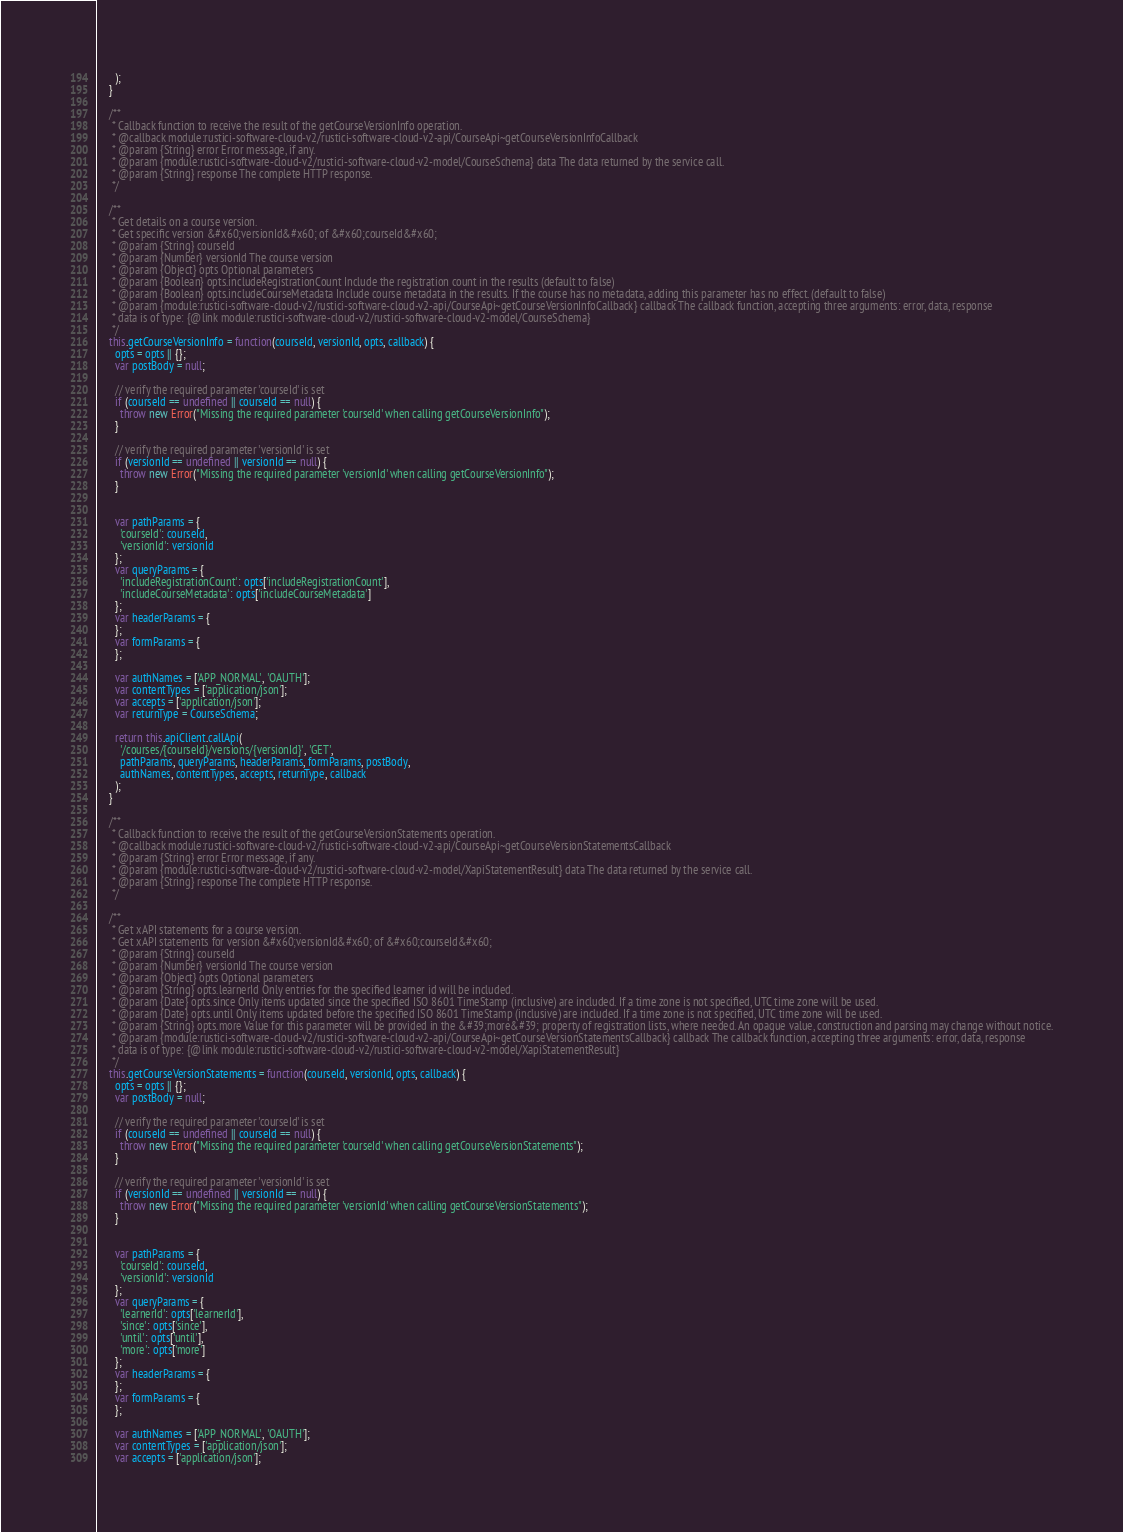<code> <loc_0><loc_0><loc_500><loc_500><_JavaScript_>      );
    }

    /**
     * Callback function to receive the result of the getCourseVersionInfo operation.
     * @callback module:rustici-software-cloud-v2/rustici-software-cloud-v2-api/CourseApi~getCourseVersionInfoCallback
     * @param {String} error Error message, if any.
     * @param {module:rustici-software-cloud-v2/rustici-software-cloud-v2-model/CourseSchema} data The data returned by the service call.
     * @param {String} response The complete HTTP response.
     */

    /**
     * Get details on a course version. 
     * Get specific version &#x60;versionId&#x60; of &#x60;courseId&#x60; 
     * @param {String} courseId 
     * @param {Number} versionId The course version
     * @param {Object} opts Optional parameters
     * @param {Boolean} opts.includeRegistrationCount Include the registration count in the results (default to false)
     * @param {Boolean} opts.includeCourseMetadata Include course metadata in the results. If the course has no metadata, adding this parameter has no effect. (default to false)
     * @param {module:rustici-software-cloud-v2/rustici-software-cloud-v2-api/CourseApi~getCourseVersionInfoCallback} callback The callback function, accepting three arguments: error, data, response
     * data is of type: {@link module:rustici-software-cloud-v2/rustici-software-cloud-v2-model/CourseSchema}
     */
    this.getCourseVersionInfo = function(courseId, versionId, opts, callback) {
      opts = opts || {};
      var postBody = null;

      // verify the required parameter 'courseId' is set
      if (courseId == undefined || courseId == null) {
        throw new Error("Missing the required parameter 'courseId' when calling getCourseVersionInfo");
      }

      // verify the required parameter 'versionId' is set
      if (versionId == undefined || versionId == null) {
        throw new Error("Missing the required parameter 'versionId' when calling getCourseVersionInfo");
      }


      var pathParams = {
        'courseId': courseId,
        'versionId': versionId
      };
      var queryParams = {
        'includeRegistrationCount': opts['includeRegistrationCount'],
        'includeCourseMetadata': opts['includeCourseMetadata']
      };
      var headerParams = {
      };
      var formParams = {
      };

      var authNames = ['APP_NORMAL', 'OAUTH'];
      var contentTypes = ['application/json'];
      var accepts = ['application/json'];
      var returnType = CourseSchema;

      return this.apiClient.callApi(
        '/courses/{courseId}/versions/{versionId}', 'GET',
        pathParams, queryParams, headerParams, formParams, postBody,
        authNames, contentTypes, accepts, returnType, callback
      );
    }

    /**
     * Callback function to receive the result of the getCourseVersionStatements operation.
     * @callback module:rustici-software-cloud-v2/rustici-software-cloud-v2-api/CourseApi~getCourseVersionStatementsCallback
     * @param {String} error Error message, if any.
     * @param {module:rustici-software-cloud-v2/rustici-software-cloud-v2-model/XapiStatementResult} data The data returned by the service call.
     * @param {String} response The complete HTTP response.
     */

    /**
     * Get xAPI statements for a course version. 
     * Get xAPI statements for version &#x60;versionId&#x60; of &#x60;courseId&#x60; 
     * @param {String} courseId 
     * @param {Number} versionId The course version
     * @param {Object} opts Optional parameters
     * @param {String} opts.learnerId Only entries for the specified learner id will be included.
     * @param {Date} opts.since Only items updated since the specified ISO 8601 TimeStamp (inclusive) are included. If a time zone is not specified, UTC time zone will be used.
     * @param {Date} opts.until Only items updated before the specified ISO 8601 TimeStamp (inclusive) are included. If a time zone is not specified, UTC time zone will be used.
     * @param {String} opts.more Value for this parameter will be provided in the &#39;more&#39; property of registration lists, where needed. An opaque value, construction and parsing may change without notice.
     * @param {module:rustici-software-cloud-v2/rustici-software-cloud-v2-api/CourseApi~getCourseVersionStatementsCallback} callback The callback function, accepting three arguments: error, data, response
     * data is of type: {@link module:rustici-software-cloud-v2/rustici-software-cloud-v2-model/XapiStatementResult}
     */
    this.getCourseVersionStatements = function(courseId, versionId, opts, callback) {
      opts = opts || {};
      var postBody = null;

      // verify the required parameter 'courseId' is set
      if (courseId == undefined || courseId == null) {
        throw new Error("Missing the required parameter 'courseId' when calling getCourseVersionStatements");
      }

      // verify the required parameter 'versionId' is set
      if (versionId == undefined || versionId == null) {
        throw new Error("Missing the required parameter 'versionId' when calling getCourseVersionStatements");
      }


      var pathParams = {
        'courseId': courseId,
        'versionId': versionId
      };
      var queryParams = {
        'learnerId': opts['learnerId'],
        'since': opts['since'],
        'until': opts['until'],
        'more': opts['more']
      };
      var headerParams = {
      };
      var formParams = {
      };

      var authNames = ['APP_NORMAL', 'OAUTH'];
      var contentTypes = ['application/json'];
      var accepts = ['application/json'];</code> 